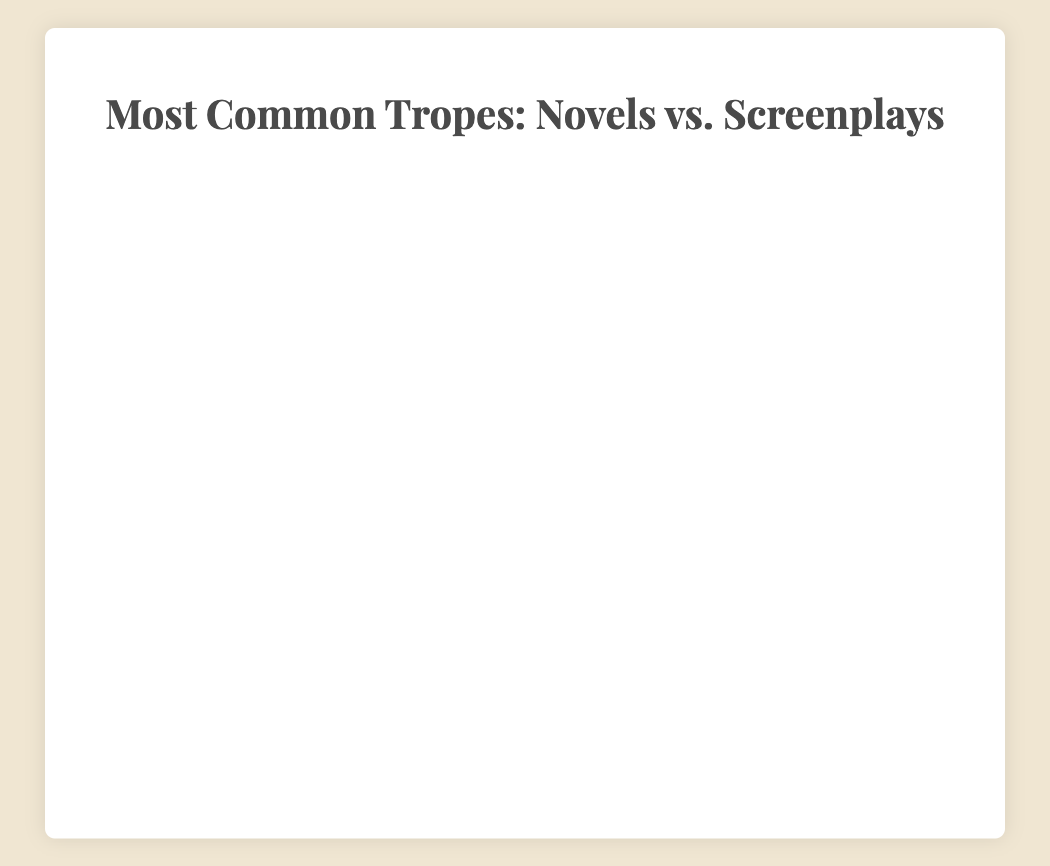What percentage of best-selling novels use the "Love Triangle" trope? According to the bar chart, the "Love Triangle" trope appears in 40% of best-selling novels.
Answer: 40% Which trope is more common in successful screenplays compared to best-selling novels: "The Chosen One" or "The Everyman"? "The Chosen One" appears in 55% of successful screenplays and 45% of best-selling novels, making it more common in successful screenplays. "The Everyman" appears in 35% of successful screenplays and 40% of best-selling novels, making it less common in successful screenplays.
Answer: The Chosen One What is the total percentage usage of the "Rags to Riches" trope across both best-selling novels and successful screenplays? The "Rags to Riches" trope appears in 35% of best-selling novels and 50% of successful screenplays. The total usage percentage is the sum of these values: 35% + 50% = 85%.
Answer: 85% Which trope has the largest difference in usage percentage between best-selling novels and successful screenplays, and what is this difference? "Love Triangle" has the largest difference, appearing in 40% of best-selling novels and 60% of successful screenplays. The difference is 60% - 40% = 20%.
Answer: Love Triangle, 20% Identify the trope with the highest usage percentage in best-selling novels and the trope with the highest usage percentage in successful screenplays. In best-selling novels, "The Anti-Hero" has the highest usage percentage at 60%. In successful screenplays, "The Anti-Hero" also has the highest usage percentage at 65%.
Answer: The Anti-Hero Which tropes have an equal usage percentage in best-selling novels and successful screenplays? According to the chart, no trope has an equal usage percentage in both best-selling novels and successful screenplays.
Answer: None What is the average percentage usage of the "Forbidden Love" trope across both best-selling novels and successful screenplays? The "Forbidden Love" trope appears in 50% of best-selling novels and 55% of successful screenplays. The average is calculated as (50 + 55) / 2 = 52.5%.
Answer: 52.5% How does the usage of "The Quest" trope compare between best-selling novels and successful screenplays? "The Quest" trope is used in 55% of best-selling novels and 40% of successful screenplays. Therefore, it is more common in best-selling novels.
Answer: More common in best-selling novels Considering the "The Mentor" trope, what percentage more or less frequent is it in best-selling novels compared to successful screenplays? "The Mentor" trope is used in 50% of best-selling novels and 45% of successful screenplays. The difference is calculated as 50% - 45% = 5%, so it is 5% more frequent in best-selling novels.
Answer: 5% more frequent 